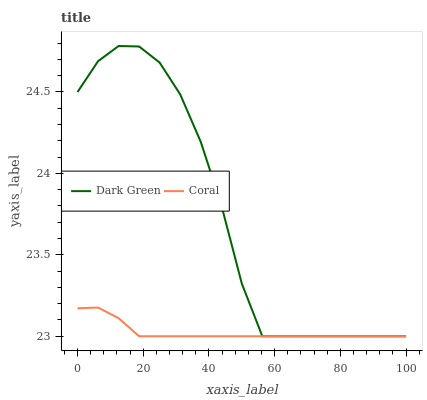Does Dark Green have the minimum area under the curve?
Answer yes or no. No. Is Dark Green the smoothest?
Answer yes or no. No. 